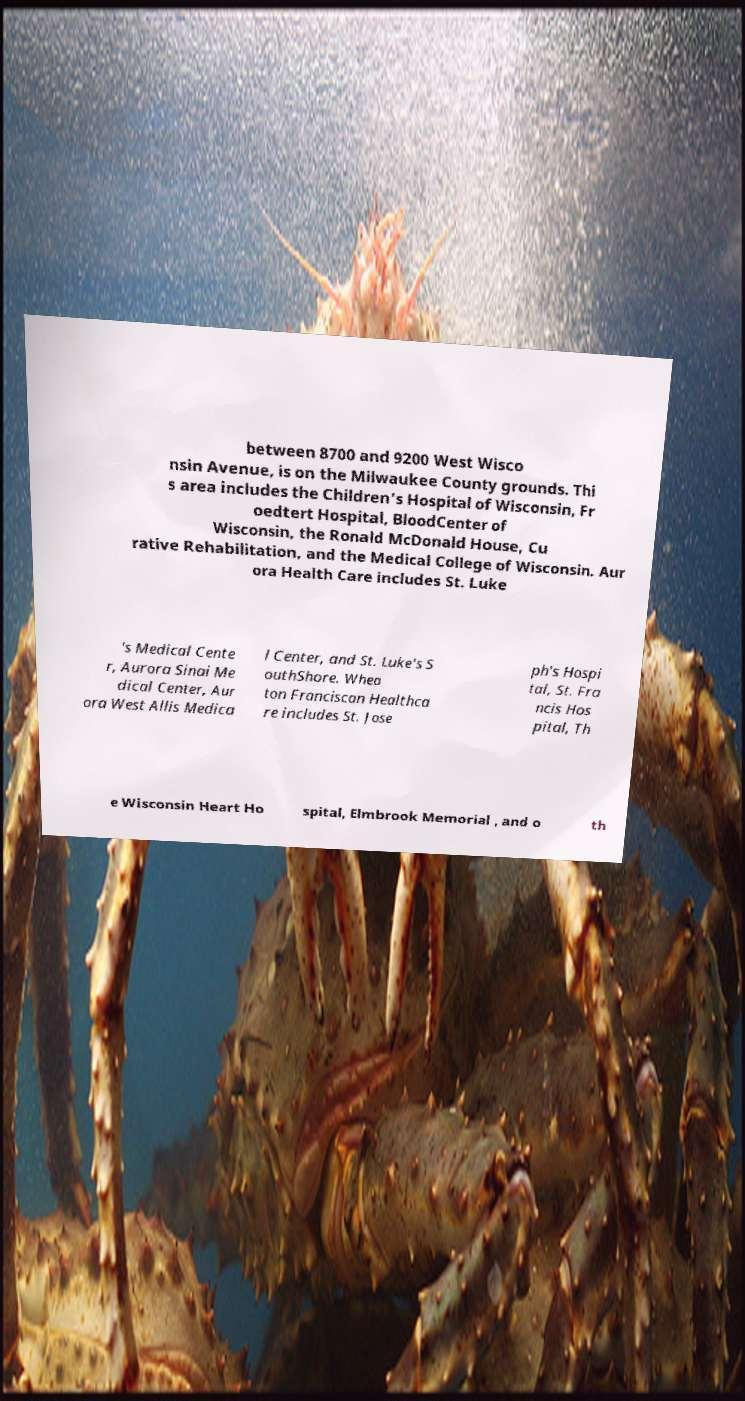Please identify and transcribe the text found in this image. between 8700 and 9200 West Wisco nsin Avenue, is on the Milwaukee County grounds. Thi s area includes the Children's Hospital of Wisconsin, Fr oedtert Hospital, BloodCenter of Wisconsin, the Ronald McDonald House, Cu rative Rehabilitation, and the Medical College of Wisconsin. Aur ora Health Care includes St. Luke 's Medical Cente r, Aurora Sinai Me dical Center, Aur ora West Allis Medica l Center, and St. Luke's S outhShore. Whea ton Franciscan Healthca re includes St. Jose ph's Hospi tal, St. Fra ncis Hos pital, Th e Wisconsin Heart Ho spital, Elmbrook Memorial , and o th 